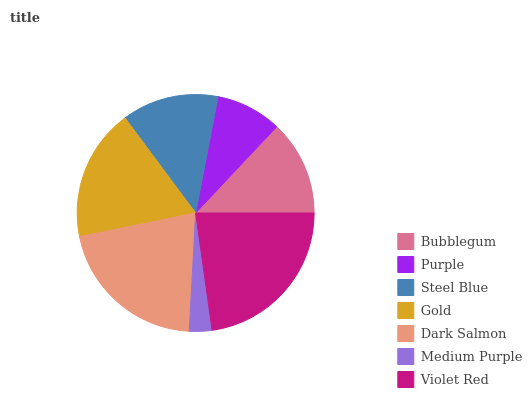Is Medium Purple the minimum?
Answer yes or no. Yes. Is Violet Red the maximum?
Answer yes or no. Yes. Is Purple the minimum?
Answer yes or no. No. Is Purple the maximum?
Answer yes or no. No. Is Bubblegum greater than Purple?
Answer yes or no. Yes. Is Purple less than Bubblegum?
Answer yes or no. Yes. Is Purple greater than Bubblegum?
Answer yes or no. No. Is Bubblegum less than Purple?
Answer yes or no. No. Is Steel Blue the high median?
Answer yes or no. Yes. Is Steel Blue the low median?
Answer yes or no. Yes. Is Violet Red the high median?
Answer yes or no. No. Is Bubblegum the low median?
Answer yes or no. No. 